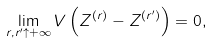<formula> <loc_0><loc_0><loc_500><loc_500>\lim _ { r , r ^ { \prime } \uparrow + \infty } V \left ( Z ^ { \left ( r \right ) } - Z ^ { \left ( r ^ { \prime } \right ) } \right ) = 0 ,</formula> 